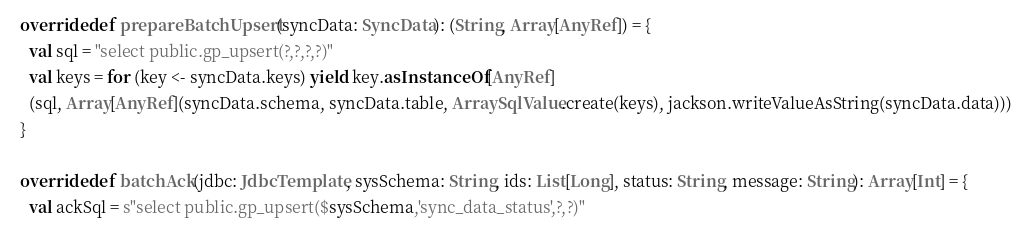Convert code to text. <code><loc_0><loc_0><loc_500><loc_500><_Scala_>
  override def prepareBatchUpsert(syncData: SyncData): (String, Array[AnyRef]) = {
    val sql = "select public.gp_upsert(?,?,?,?)"
    val keys = for (key <- syncData.keys) yield key.asInstanceOf[AnyRef]
    (sql, Array[AnyRef](syncData.schema, syncData.table, ArraySqlValue.create(keys), jackson.writeValueAsString(syncData.data)))
  }

  override def batchAck(jdbc: JdbcTemplate, sysSchema: String, ids: List[Long], status: String, message: String): Array[Int] = {
    val ackSql = s"select public.gp_upsert($sysSchema,'sync_data_status',?,?)"</code> 